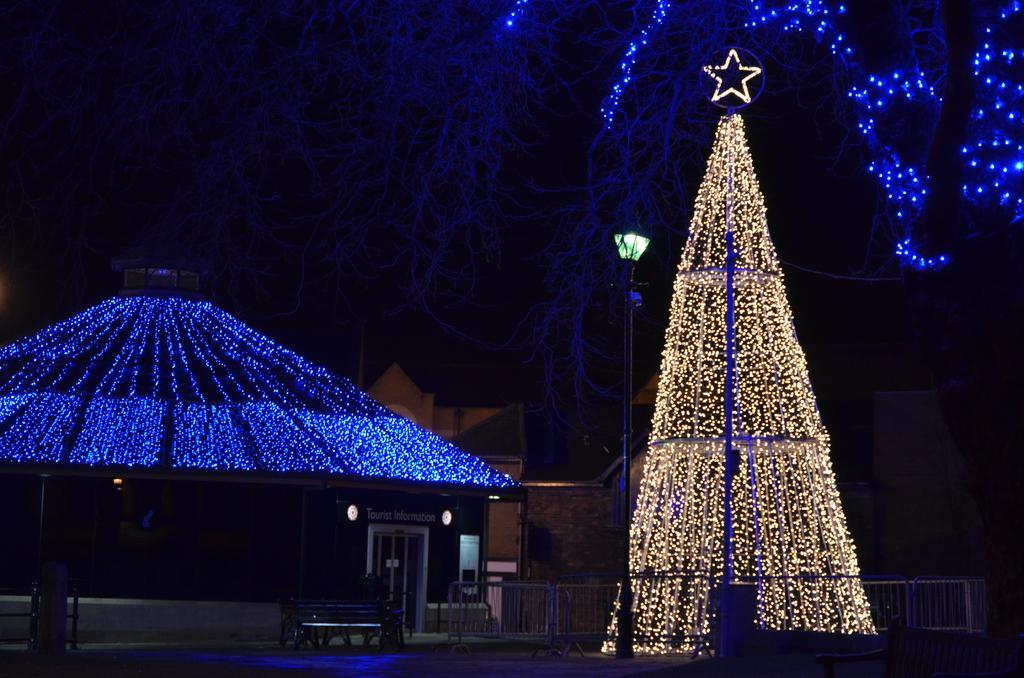How would you summarize this image in a sentence or two? In this image we can see decorative lights, pole, houses, bench, boards, and railing. There is a dark background. 